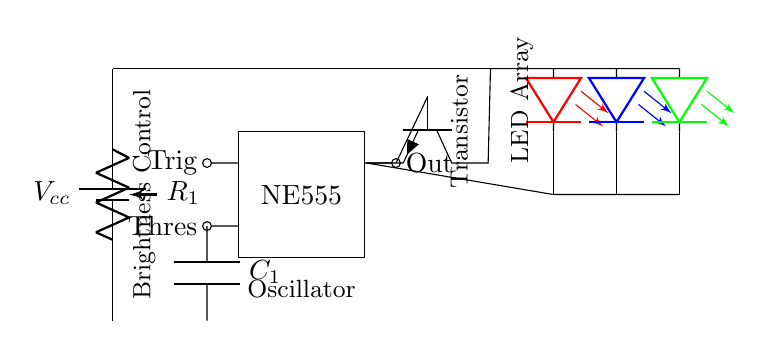What is the purpose of the potentiometer? The potentiometer, labeled R1, is used for brightness control by adjusting the resistance in the circuit, thereby varying the current flowing to the LED array.
Answer: Brightness control What type of transistor is used in this circuit? The circuit shows an npn transistor (Q1), which conducts when a sufficient voltage is applied to its base, allowing current to flow from collector to emitter.
Answer: npn How many LEDs are in the array? There are three LEDs shown in the circuit diagram, each represented in different colors: red, blue, and green.
Answer: Three What function does the NE555 timer serve in this circuit? The NE555 timer is used in astable mode to generate a pulse width modulation signal, which controls the brightness of the LEDs by turning them on and off rapidly.
Answer: Oscillator What is the connection between the NE555 timer and the transistor? The output from the NE555 timer connects to the base of the npn transistor, allowing the timer to control the transistor's operation and hence the LED brightness.
Answer: Base connection What effect does the capacitor C1 have on the circuit? The capacitor (C1) in this circuit affects the frequency of the oscillations generated by the NE555 timer, thereby influencing the blinking rate of the LED mood lighting.
Answer: Frequency control 